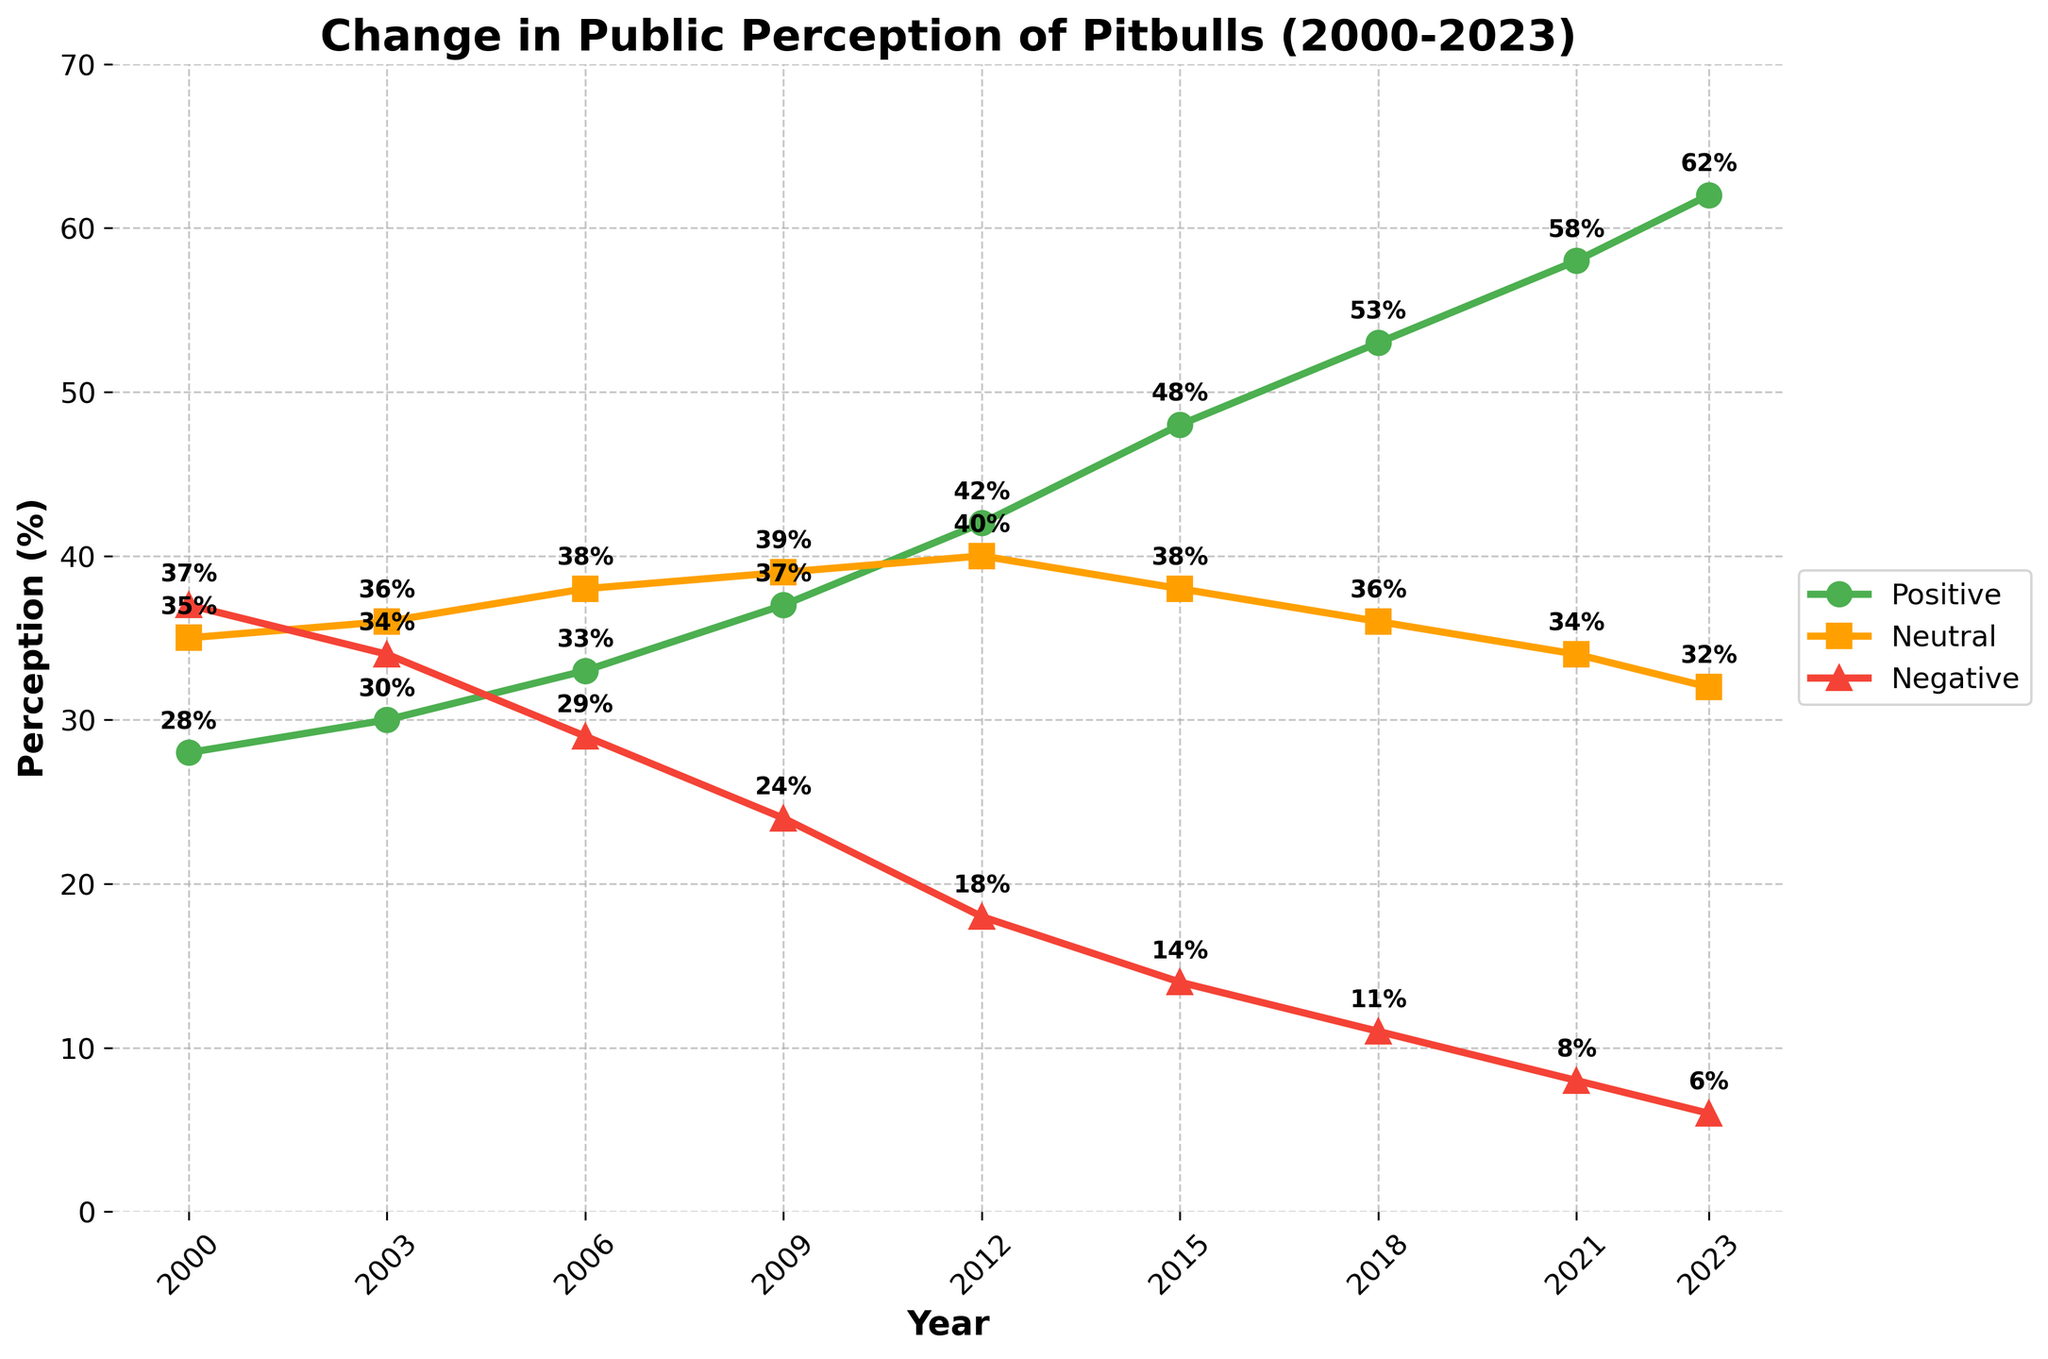Which year had the highest positive perception of pitbulls? By examining the figure, the positive perception of pitbulls increases over time. The highest value can be found at the end of the timeline. The year 2023 shows the highest positive perception.
Answer: 2023 What is the difference in negative perception between 2000 and 2023? In the figure, the negative perception of pitbulls in 2000 is 37%, and in 2023, it is 6%. The difference is calculated as 37% - 6%.
Answer: 31% How did neutral perception change from 2000 to 2023? Observing the figure, in 2000, the neutral perception is 35% and in 2023, it is 32%. The change is calculated as 32% - 35%.
Answer: Decreased by 3% What is the trend in positive perception of pitbulls from 2000 to 2023? The trend is observed in the figure by looking at the line representing positive perception from 2000 to 2023. The line shows an increase over these years.
Answer: Increasing Which year marks the first time when positive perception exceeds negative perception? By comparing the lines for positive and negative perceptions on the figure, in 2009, the positive perception of 37% exceeds the negative perception of 24%.
Answer: 2009 What is the average positive perception of pitbulls from 2000 to 2023? The average is found by summing the positive perceptions for each year and dividing by the number of years: (28 + 30 + 33 + 37 + 42 + 48 + 53 + 58 + 62) / 9. This equals 391 / 9.
Answer: 43.44% Which perception showed the most significant decrease between any two consecutive years? By examining the changes between each consecutive year for positive, neutral, and negative perceptions, the most significant decrease is seen in negative perception between 2012 (18%) and 2015 (14%). The decrease is calculated as 18% - 14%.
Answer: Negative perception between 2012 and 2015 At which data points do the neutral perception lines intersect with positive or negative perception lines? Intersections can be observed by looking at the points where the lines cross each other in the figure. The neutral perception line does not intersect with either positive or negative perception lines from 2000 to 2023.
Answer: None 